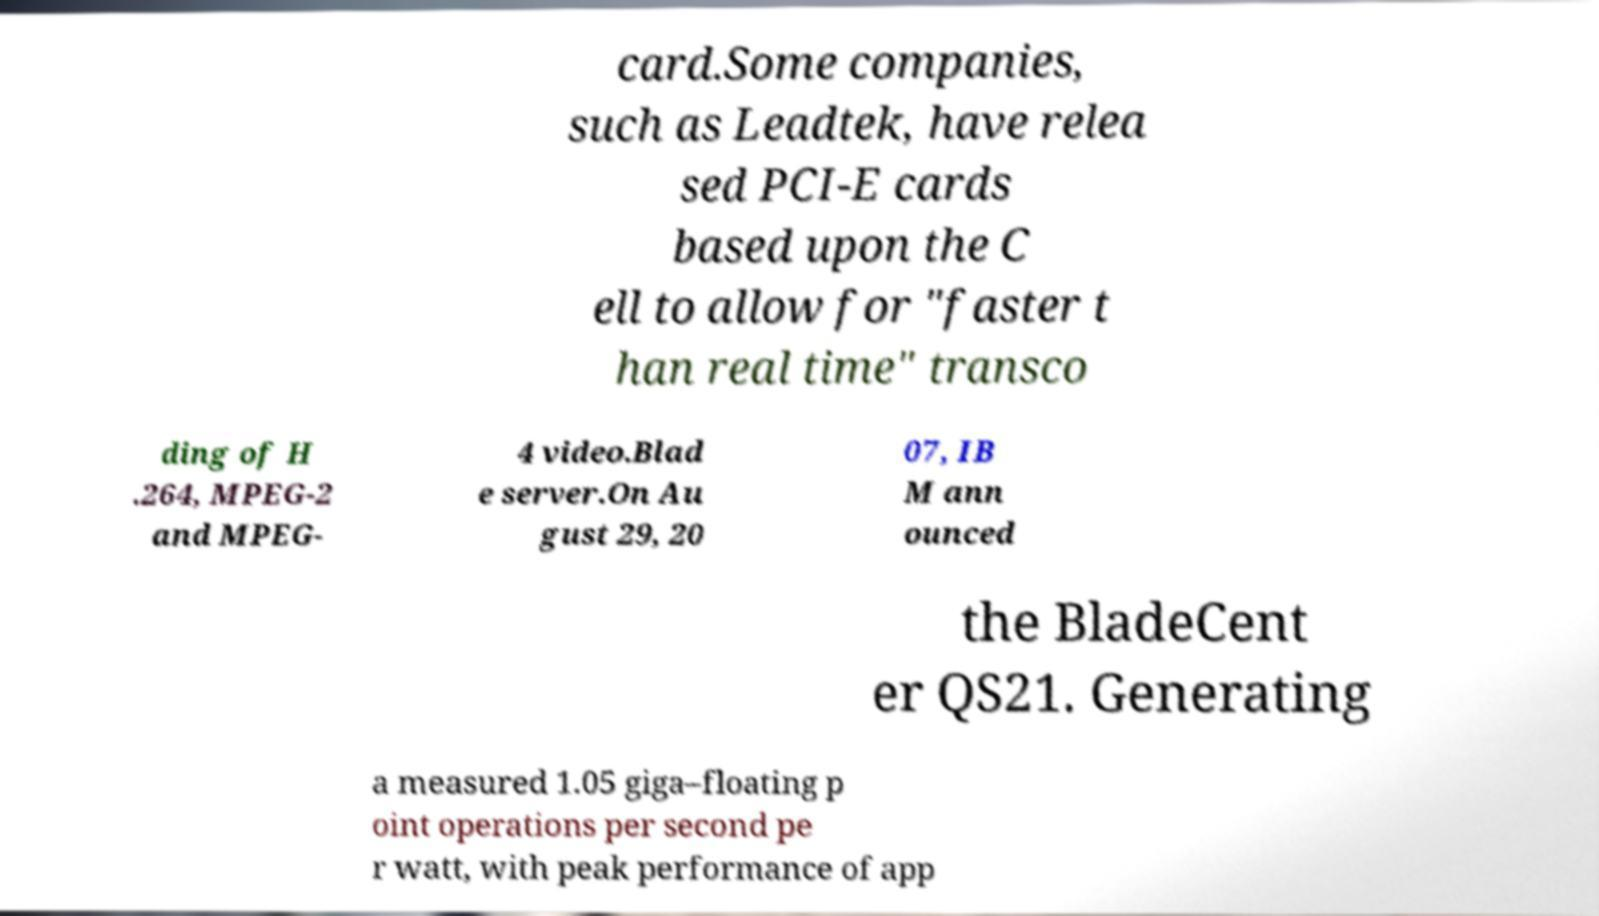Please read and relay the text visible in this image. What does it say? card.Some companies, such as Leadtek, have relea sed PCI-E cards based upon the C ell to allow for "faster t han real time" transco ding of H .264, MPEG-2 and MPEG- 4 video.Blad e server.On Au gust 29, 20 07, IB M ann ounced the BladeCent er QS21. Generating a measured 1.05 giga–floating p oint operations per second pe r watt, with peak performance of app 